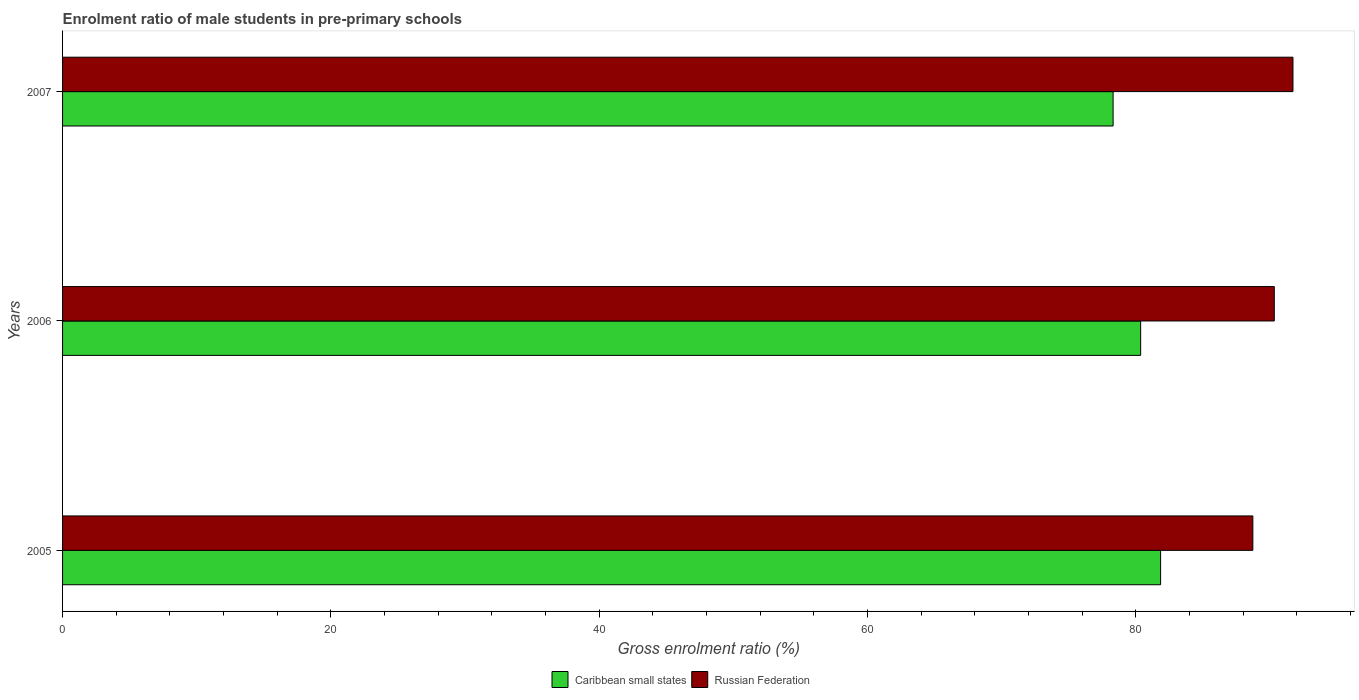How many different coloured bars are there?
Your answer should be compact. 2. Are the number of bars on each tick of the Y-axis equal?
Keep it short and to the point. Yes. What is the label of the 2nd group of bars from the top?
Keep it short and to the point. 2006. In how many cases, is the number of bars for a given year not equal to the number of legend labels?
Offer a terse response. 0. What is the enrolment ratio of male students in pre-primary schools in Caribbean small states in 2006?
Ensure brevity in your answer.  80.36. Across all years, what is the maximum enrolment ratio of male students in pre-primary schools in Russian Federation?
Provide a succinct answer. 91.72. Across all years, what is the minimum enrolment ratio of male students in pre-primary schools in Caribbean small states?
Offer a very short reply. 78.31. What is the total enrolment ratio of male students in pre-primary schools in Russian Federation in the graph?
Your response must be concise. 270.77. What is the difference between the enrolment ratio of male students in pre-primary schools in Caribbean small states in 2006 and that in 2007?
Keep it short and to the point. 2.05. What is the difference between the enrolment ratio of male students in pre-primary schools in Caribbean small states in 2006 and the enrolment ratio of male students in pre-primary schools in Russian Federation in 2005?
Your answer should be compact. -8.36. What is the average enrolment ratio of male students in pre-primary schools in Russian Federation per year?
Give a very brief answer. 90.26. In the year 2006, what is the difference between the enrolment ratio of male students in pre-primary schools in Russian Federation and enrolment ratio of male students in pre-primary schools in Caribbean small states?
Offer a terse response. 9.96. In how many years, is the enrolment ratio of male students in pre-primary schools in Caribbean small states greater than 56 %?
Make the answer very short. 3. What is the ratio of the enrolment ratio of male students in pre-primary schools in Caribbean small states in 2005 to that in 2007?
Ensure brevity in your answer.  1.05. Is the enrolment ratio of male students in pre-primary schools in Caribbean small states in 2006 less than that in 2007?
Your answer should be very brief. No. What is the difference between the highest and the second highest enrolment ratio of male students in pre-primary schools in Caribbean small states?
Your response must be concise. 1.49. What is the difference between the highest and the lowest enrolment ratio of male students in pre-primary schools in Caribbean small states?
Keep it short and to the point. 3.54. What does the 1st bar from the top in 2005 represents?
Your answer should be compact. Russian Federation. What does the 2nd bar from the bottom in 2006 represents?
Give a very brief answer. Russian Federation. Are all the bars in the graph horizontal?
Give a very brief answer. Yes. How many years are there in the graph?
Your response must be concise. 3. Does the graph contain grids?
Give a very brief answer. No. How are the legend labels stacked?
Give a very brief answer. Horizontal. What is the title of the graph?
Offer a very short reply. Enrolment ratio of male students in pre-primary schools. Does "Morocco" appear as one of the legend labels in the graph?
Keep it short and to the point. No. What is the label or title of the Y-axis?
Offer a terse response. Years. What is the Gross enrolment ratio (%) of Caribbean small states in 2005?
Your answer should be very brief. 81.85. What is the Gross enrolment ratio (%) of Russian Federation in 2005?
Your answer should be very brief. 88.73. What is the Gross enrolment ratio (%) in Caribbean small states in 2006?
Ensure brevity in your answer.  80.36. What is the Gross enrolment ratio (%) of Russian Federation in 2006?
Give a very brief answer. 90.33. What is the Gross enrolment ratio (%) of Caribbean small states in 2007?
Provide a succinct answer. 78.31. What is the Gross enrolment ratio (%) in Russian Federation in 2007?
Your response must be concise. 91.72. Across all years, what is the maximum Gross enrolment ratio (%) in Caribbean small states?
Ensure brevity in your answer.  81.85. Across all years, what is the maximum Gross enrolment ratio (%) in Russian Federation?
Offer a very short reply. 91.72. Across all years, what is the minimum Gross enrolment ratio (%) of Caribbean small states?
Provide a succinct answer. 78.31. Across all years, what is the minimum Gross enrolment ratio (%) of Russian Federation?
Your answer should be compact. 88.73. What is the total Gross enrolment ratio (%) of Caribbean small states in the graph?
Your answer should be very brief. 240.53. What is the total Gross enrolment ratio (%) of Russian Federation in the graph?
Make the answer very short. 270.77. What is the difference between the Gross enrolment ratio (%) in Caribbean small states in 2005 and that in 2006?
Ensure brevity in your answer.  1.49. What is the difference between the Gross enrolment ratio (%) of Russian Federation in 2005 and that in 2006?
Give a very brief answer. -1.6. What is the difference between the Gross enrolment ratio (%) of Caribbean small states in 2005 and that in 2007?
Ensure brevity in your answer.  3.54. What is the difference between the Gross enrolment ratio (%) in Russian Federation in 2005 and that in 2007?
Offer a terse response. -2.99. What is the difference between the Gross enrolment ratio (%) in Caribbean small states in 2006 and that in 2007?
Your response must be concise. 2.05. What is the difference between the Gross enrolment ratio (%) in Russian Federation in 2006 and that in 2007?
Your answer should be compact. -1.39. What is the difference between the Gross enrolment ratio (%) of Caribbean small states in 2005 and the Gross enrolment ratio (%) of Russian Federation in 2006?
Make the answer very short. -8.47. What is the difference between the Gross enrolment ratio (%) in Caribbean small states in 2005 and the Gross enrolment ratio (%) in Russian Federation in 2007?
Your response must be concise. -9.87. What is the difference between the Gross enrolment ratio (%) in Caribbean small states in 2006 and the Gross enrolment ratio (%) in Russian Federation in 2007?
Give a very brief answer. -11.35. What is the average Gross enrolment ratio (%) in Caribbean small states per year?
Offer a terse response. 80.18. What is the average Gross enrolment ratio (%) in Russian Federation per year?
Your response must be concise. 90.26. In the year 2005, what is the difference between the Gross enrolment ratio (%) in Caribbean small states and Gross enrolment ratio (%) in Russian Federation?
Your answer should be compact. -6.88. In the year 2006, what is the difference between the Gross enrolment ratio (%) in Caribbean small states and Gross enrolment ratio (%) in Russian Federation?
Ensure brevity in your answer.  -9.96. In the year 2007, what is the difference between the Gross enrolment ratio (%) of Caribbean small states and Gross enrolment ratio (%) of Russian Federation?
Ensure brevity in your answer.  -13.41. What is the ratio of the Gross enrolment ratio (%) in Caribbean small states in 2005 to that in 2006?
Offer a very short reply. 1.02. What is the ratio of the Gross enrolment ratio (%) of Russian Federation in 2005 to that in 2006?
Your answer should be very brief. 0.98. What is the ratio of the Gross enrolment ratio (%) of Caribbean small states in 2005 to that in 2007?
Your answer should be compact. 1.05. What is the ratio of the Gross enrolment ratio (%) in Russian Federation in 2005 to that in 2007?
Provide a short and direct response. 0.97. What is the ratio of the Gross enrolment ratio (%) of Caribbean small states in 2006 to that in 2007?
Ensure brevity in your answer.  1.03. What is the ratio of the Gross enrolment ratio (%) of Russian Federation in 2006 to that in 2007?
Provide a succinct answer. 0.98. What is the difference between the highest and the second highest Gross enrolment ratio (%) of Caribbean small states?
Give a very brief answer. 1.49. What is the difference between the highest and the second highest Gross enrolment ratio (%) in Russian Federation?
Give a very brief answer. 1.39. What is the difference between the highest and the lowest Gross enrolment ratio (%) in Caribbean small states?
Offer a very short reply. 3.54. What is the difference between the highest and the lowest Gross enrolment ratio (%) in Russian Federation?
Keep it short and to the point. 2.99. 